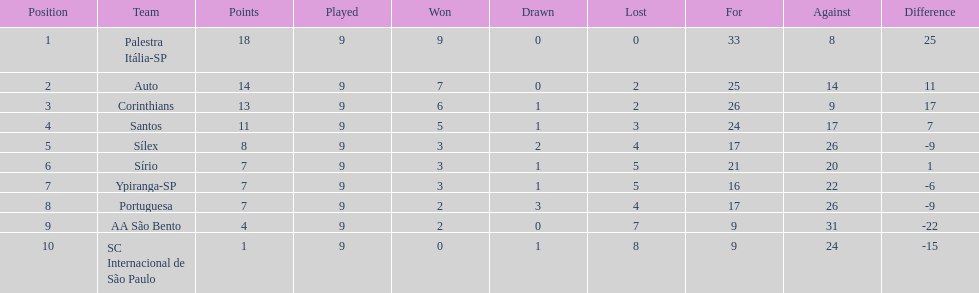Which team uniquely scored 13 points across a span of 9 games? Corinthians. Would you be able to parse every entry in this table? {'header': ['Position', 'Team', 'Points', 'Played', 'Won', 'Drawn', 'Lost', 'For', 'Against', 'Difference'], 'rows': [['1', 'Palestra Itália-SP', '18', '9', '9', '0', '0', '33', '8', '25'], ['2', 'Auto', '14', '9', '7', '0', '2', '25', '14', '11'], ['3', 'Corinthians', '13', '9', '6', '1', '2', '26', '9', '17'], ['4', 'Santos', '11', '9', '5', '1', '3', '24', '17', '7'], ['5', 'Sílex', '8', '9', '3', '2', '4', '17', '26', '-9'], ['6', 'Sírio', '7', '9', '3', '1', '5', '21', '20', '1'], ['7', 'Ypiranga-SP', '7', '9', '3', '1', '5', '16', '22', '-6'], ['8', 'Portuguesa', '7', '9', '2', '3', '4', '17', '26', '-9'], ['9', 'AA São Bento', '4', '9', '2', '0', '7', '9', '31', '-22'], ['10', 'SC Internacional de São Paulo', '1', '9', '0', '1', '8', '9', '24', '-15']]} 